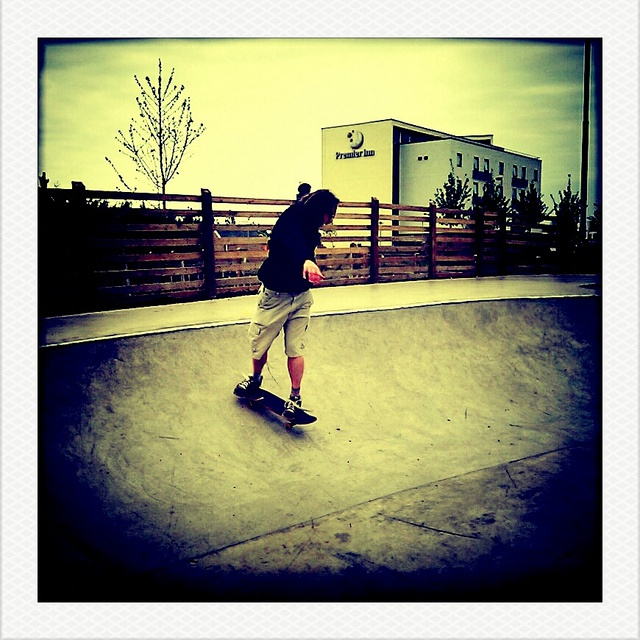Describe the objects in this image and their specific colors. I can see people in lightgray, black, tan, khaki, and gray tones and skateboard in lightgray, navy, and gray tones in this image. 